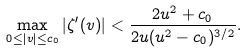Convert formula to latex. <formula><loc_0><loc_0><loc_500><loc_500>\max _ { 0 \leq | v | \leq c _ { 0 } } | \zeta ^ { \prime } ( v ) | < \frac { 2 u ^ { 2 } + c _ { 0 } } { 2 u ( u ^ { 2 } - c _ { 0 } ) ^ { 3 / 2 } } .</formula> 